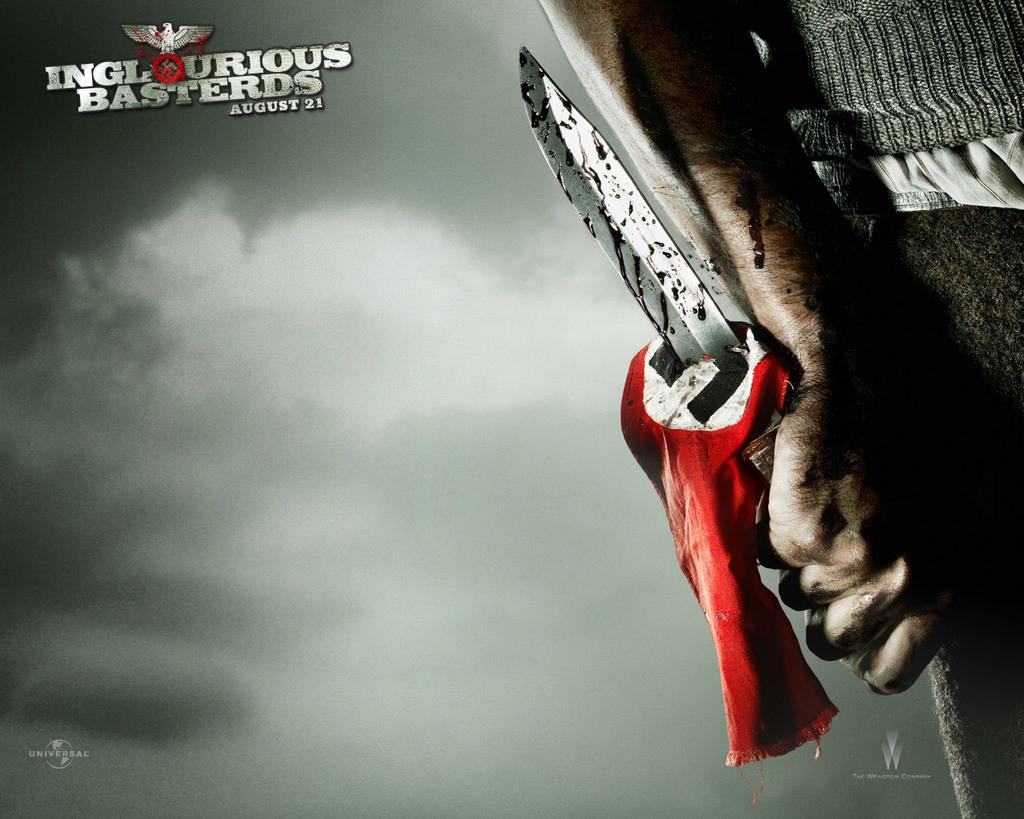What is present in the image? There is a poster in the image. What is depicted on the poster? The poster features a person holding a knife. Can you see any volleyball players in the image? There are no volleyball players present in the image; it only features a poster with a person holding a knife. 